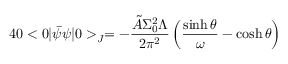<formula> <loc_0><loc_0><loc_500><loc_500>4 0 < 0 | \bar { \psi } \psi | 0 > _ { J } = - \frac { \tilde { A } \Sigma _ { 0 } ^ { 2 } \Lambda } { 2 \pi ^ { 2 } } \left ( \frac { \sinh \theta } { \omega } - \cosh \theta \right )</formula> 